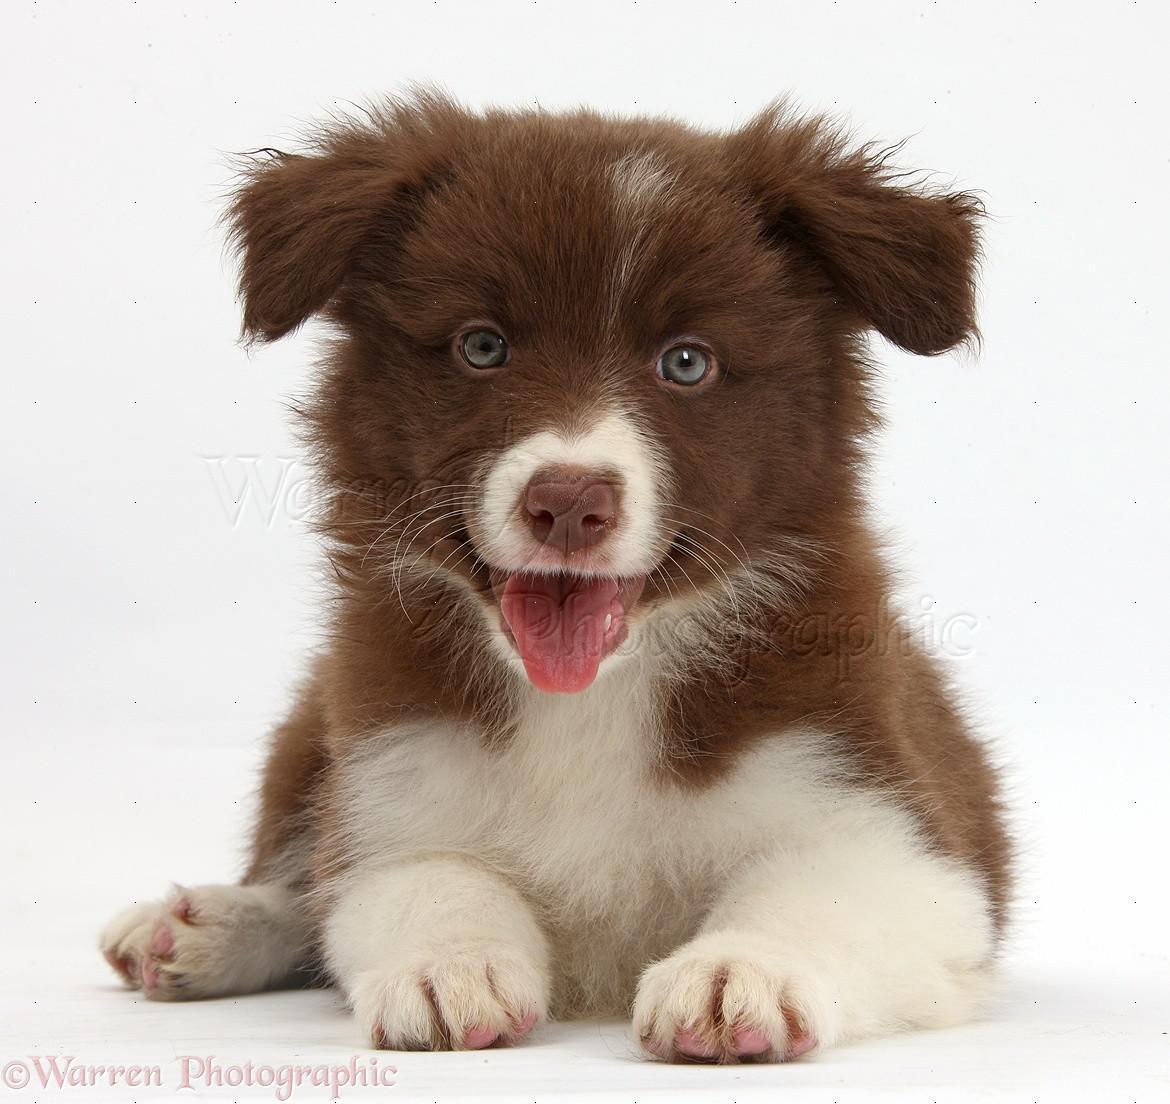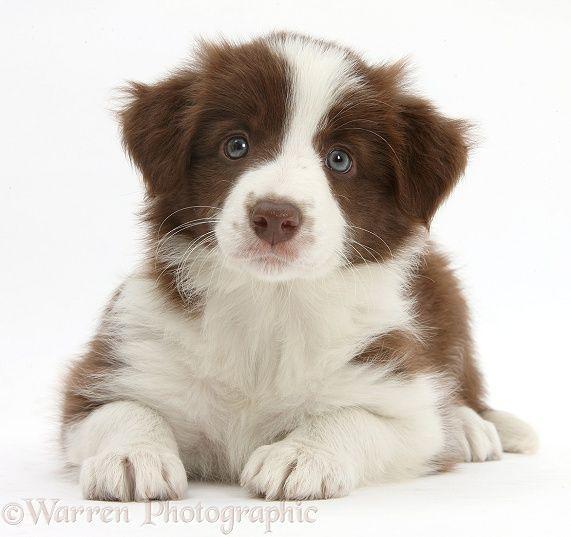The first image is the image on the left, the second image is the image on the right. Considering the images on both sides, is "One brown and white dog has its mouth open with tongue showing and one does not, but both have wide white bands of color between their eyes." valid? Answer yes or no. No. The first image is the image on the left, the second image is the image on the right. For the images shown, is this caption "The combined images include two brown-and-white dogs reclining with front paws extended forward." true? Answer yes or no. Yes. 